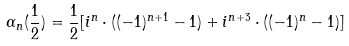<formula> <loc_0><loc_0><loc_500><loc_500>\alpha { _ { n } ( \frac { 1 } { 2 } ) } = \frac { 1 } { 2 } [ i ^ { n } \cdot ( ( - 1 ) ^ { n + 1 } - 1 ) + i ^ { n + 3 } \cdot ( ( - 1 ) ^ { n } - 1 ) ]</formula> 